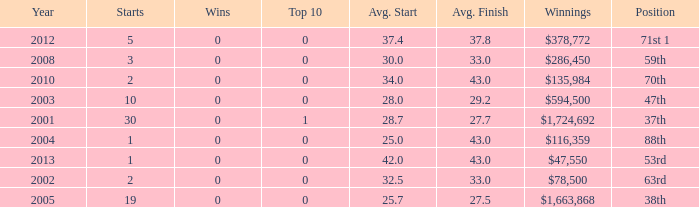How many starts for an average finish greater than 43? None. 